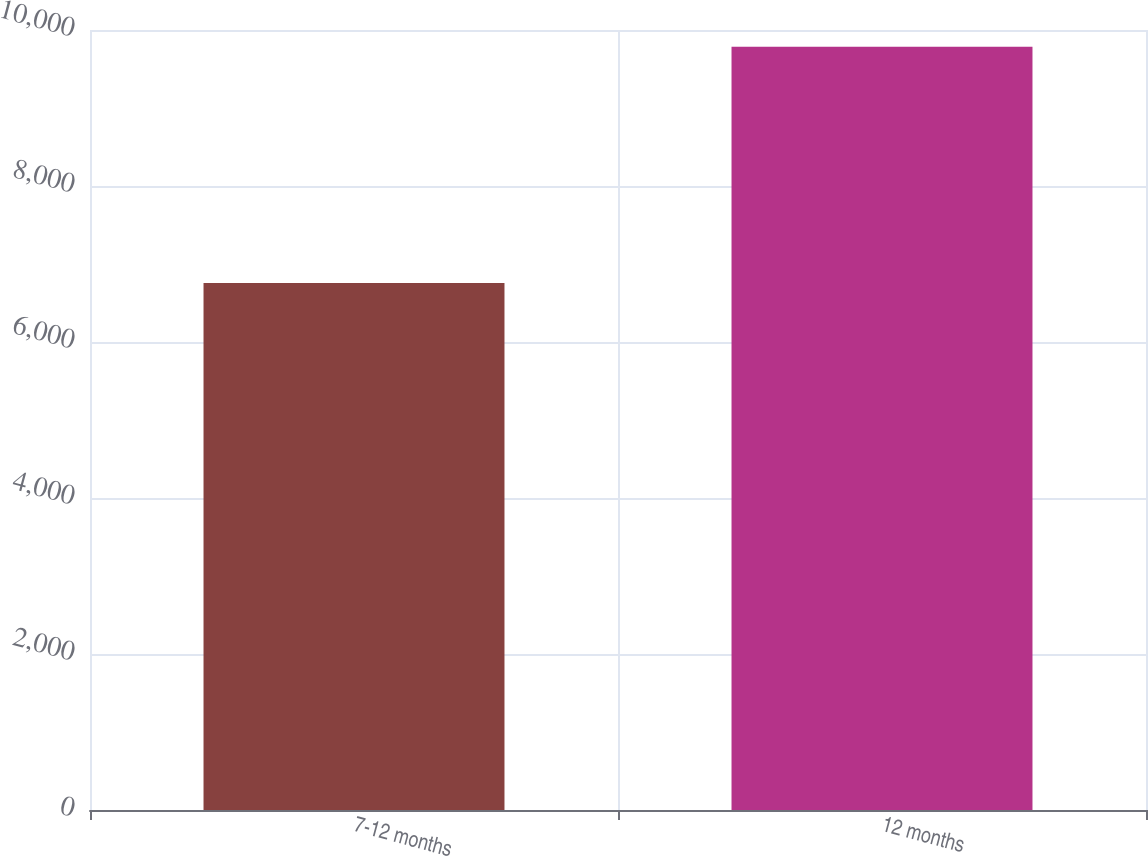<chart> <loc_0><loc_0><loc_500><loc_500><bar_chart><fcel>7-12 months<fcel>12 months<nl><fcel>6756<fcel>9785<nl></chart> 